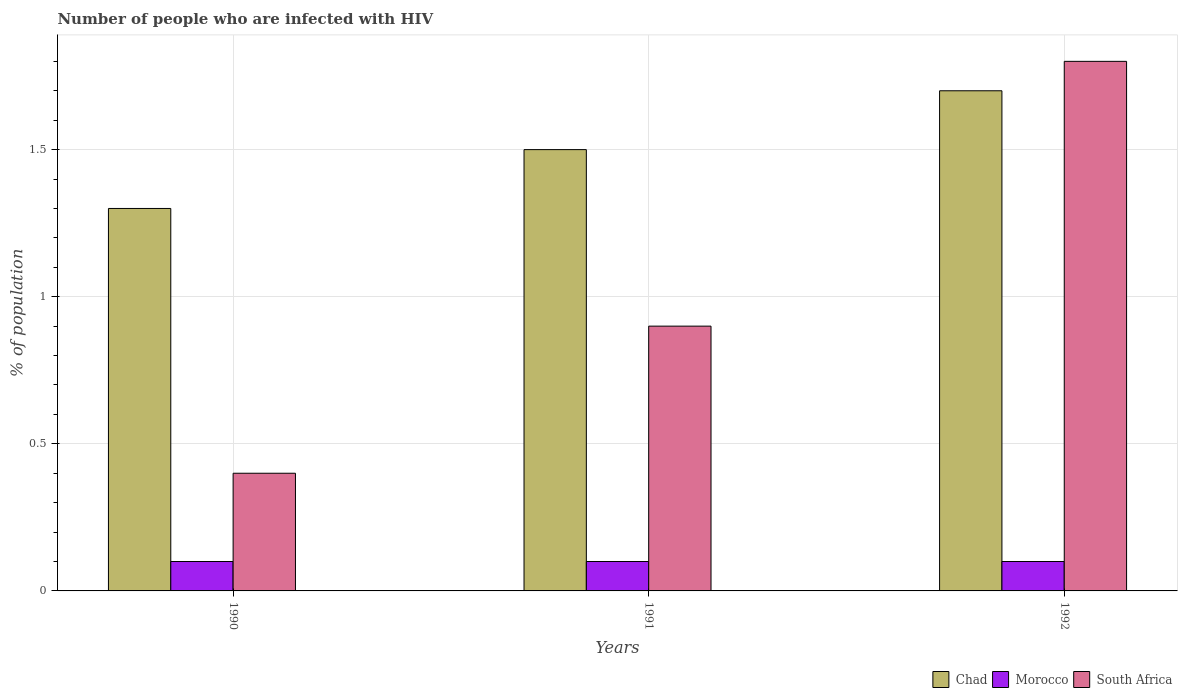Are the number of bars on each tick of the X-axis equal?
Your answer should be compact. Yes. How many bars are there on the 3rd tick from the left?
Your answer should be compact. 3. How many bars are there on the 3rd tick from the right?
Your answer should be compact. 3. What is the label of the 1st group of bars from the left?
Provide a short and direct response. 1990. In how many cases, is the number of bars for a given year not equal to the number of legend labels?
Provide a short and direct response. 0. Across all years, what is the minimum percentage of HIV infected population in in Chad?
Provide a succinct answer. 1.3. In which year was the percentage of HIV infected population in in South Africa minimum?
Your answer should be very brief. 1990. What is the difference between the percentage of HIV infected population in in Morocco in 1990 and that in 1991?
Offer a terse response. 0. What is the difference between the percentage of HIV infected population in in Chad in 1992 and the percentage of HIV infected population in in South Africa in 1991?
Keep it short and to the point. 0.8. What is the average percentage of HIV infected population in in South Africa per year?
Provide a short and direct response. 1.03. What is the ratio of the percentage of HIV infected population in in Morocco in 1990 to that in 1991?
Offer a very short reply. 1. Is the percentage of HIV infected population in in Morocco in 1990 less than that in 1991?
Give a very brief answer. No. What is the difference between the highest and the second highest percentage of HIV infected population in in Chad?
Your answer should be very brief. 0.2. In how many years, is the percentage of HIV infected population in in Chad greater than the average percentage of HIV infected population in in Chad taken over all years?
Provide a short and direct response. 1. Is the sum of the percentage of HIV infected population in in Chad in 1991 and 1992 greater than the maximum percentage of HIV infected population in in Morocco across all years?
Offer a very short reply. Yes. What does the 2nd bar from the left in 1992 represents?
Ensure brevity in your answer.  Morocco. What does the 1st bar from the right in 1990 represents?
Ensure brevity in your answer.  South Africa. Is it the case that in every year, the sum of the percentage of HIV infected population in in Chad and percentage of HIV infected population in in South Africa is greater than the percentage of HIV infected population in in Morocco?
Offer a terse response. Yes. How many bars are there?
Your answer should be very brief. 9. Are all the bars in the graph horizontal?
Your answer should be very brief. No. What is the difference between two consecutive major ticks on the Y-axis?
Keep it short and to the point. 0.5. Are the values on the major ticks of Y-axis written in scientific E-notation?
Provide a succinct answer. No. Does the graph contain grids?
Ensure brevity in your answer.  Yes. Where does the legend appear in the graph?
Give a very brief answer. Bottom right. How are the legend labels stacked?
Make the answer very short. Horizontal. What is the title of the graph?
Offer a terse response. Number of people who are infected with HIV. Does "South Sudan" appear as one of the legend labels in the graph?
Offer a very short reply. No. What is the label or title of the Y-axis?
Offer a very short reply. % of population. What is the % of population of Morocco in 1990?
Your answer should be very brief. 0.1. What is the % of population in Chad in 1992?
Offer a terse response. 1.7. What is the % of population in Morocco in 1992?
Offer a very short reply. 0.1. What is the % of population in South Africa in 1992?
Provide a succinct answer. 1.8. Across all years, what is the maximum % of population of Chad?
Provide a succinct answer. 1.7. Across all years, what is the maximum % of population of Morocco?
Make the answer very short. 0.1. Across all years, what is the minimum % of population of Chad?
Ensure brevity in your answer.  1.3. Across all years, what is the minimum % of population of Morocco?
Ensure brevity in your answer.  0.1. What is the total % of population of Chad in the graph?
Make the answer very short. 4.5. What is the total % of population of Morocco in the graph?
Your response must be concise. 0.3. What is the total % of population in South Africa in the graph?
Provide a succinct answer. 3.1. What is the difference between the % of population of Morocco in 1990 and that in 1991?
Provide a succinct answer. 0. What is the difference between the % of population of Morocco in 1990 and that in 1992?
Keep it short and to the point. 0. What is the difference between the % of population in South Africa in 1990 and that in 1992?
Make the answer very short. -1.4. What is the difference between the % of population in Chad in 1990 and the % of population in South Africa in 1991?
Provide a short and direct response. 0.4. What is the difference between the % of population of Chad in 1990 and the % of population of South Africa in 1992?
Provide a succinct answer. -0.5. What is the average % of population of Chad per year?
Your answer should be compact. 1.5. In the year 1990, what is the difference between the % of population in Chad and % of population in Morocco?
Offer a terse response. 1.2. In the year 1990, what is the difference between the % of population in Chad and % of population in South Africa?
Your answer should be compact. 0.9. In the year 1991, what is the difference between the % of population in Chad and % of population in South Africa?
Your answer should be very brief. 0.6. In the year 1991, what is the difference between the % of population of Morocco and % of population of South Africa?
Ensure brevity in your answer.  -0.8. In the year 1992, what is the difference between the % of population of Chad and % of population of Morocco?
Offer a very short reply. 1.6. In the year 1992, what is the difference between the % of population in Chad and % of population in South Africa?
Your answer should be very brief. -0.1. In the year 1992, what is the difference between the % of population in Morocco and % of population in South Africa?
Ensure brevity in your answer.  -1.7. What is the ratio of the % of population of Chad in 1990 to that in 1991?
Make the answer very short. 0.87. What is the ratio of the % of population of South Africa in 1990 to that in 1991?
Ensure brevity in your answer.  0.44. What is the ratio of the % of population of Chad in 1990 to that in 1992?
Ensure brevity in your answer.  0.76. What is the ratio of the % of population in Morocco in 1990 to that in 1992?
Your answer should be very brief. 1. What is the ratio of the % of population of South Africa in 1990 to that in 1992?
Your answer should be compact. 0.22. What is the ratio of the % of population of Chad in 1991 to that in 1992?
Your response must be concise. 0.88. What is the ratio of the % of population of Morocco in 1991 to that in 1992?
Your response must be concise. 1. What is the difference between the highest and the second highest % of population in Morocco?
Your response must be concise. 0. What is the difference between the highest and the second highest % of population in South Africa?
Your response must be concise. 0.9. What is the difference between the highest and the lowest % of population in Chad?
Your response must be concise. 0.4. 